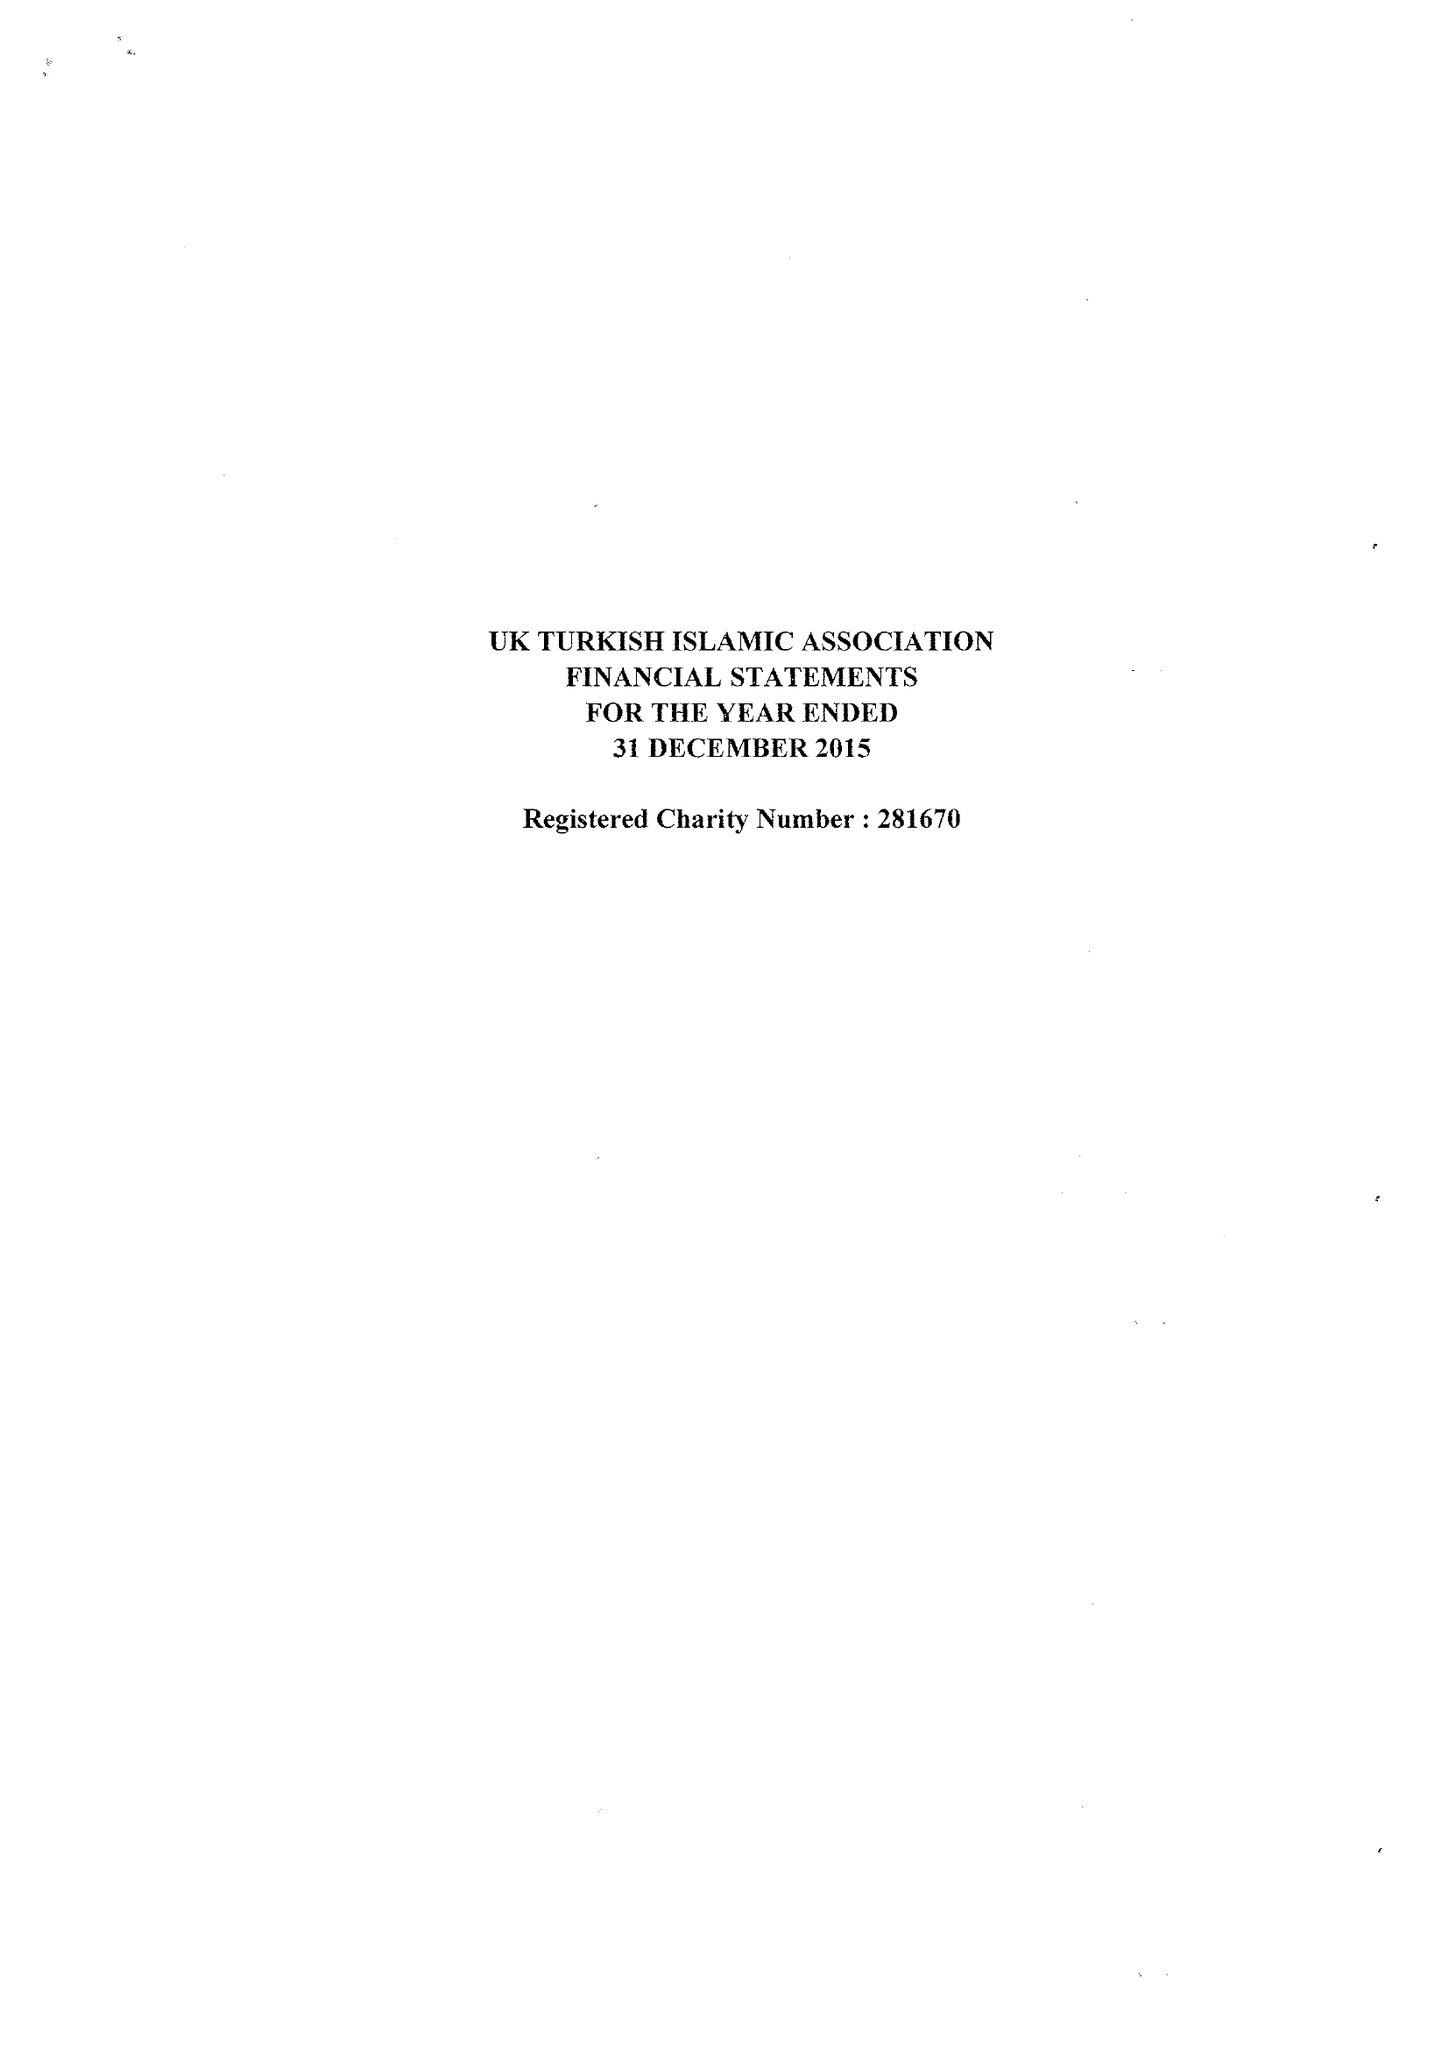What is the value for the address__post_town?
Answer the question using a single word or phrase. LONDON 